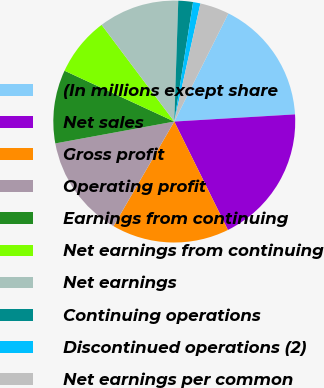Convert chart to OTSL. <chart><loc_0><loc_0><loc_500><loc_500><pie_chart><fcel>(In millions except share<fcel>Net sales<fcel>Gross profit<fcel>Operating profit<fcel>Earnings from continuing<fcel>Net earnings from continuing<fcel>Net earnings<fcel>Continuing operations<fcel>Discontinued operations (2)<fcel>Net earnings per common<nl><fcel>16.67%<fcel>18.63%<fcel>15.69%<fcel>13.73%<fcel>9.8%<fcel>7.84%<fcel>10.78%<fcel>1.96%<fcel>0.98%<fcel>3.92%<nl></chart> 